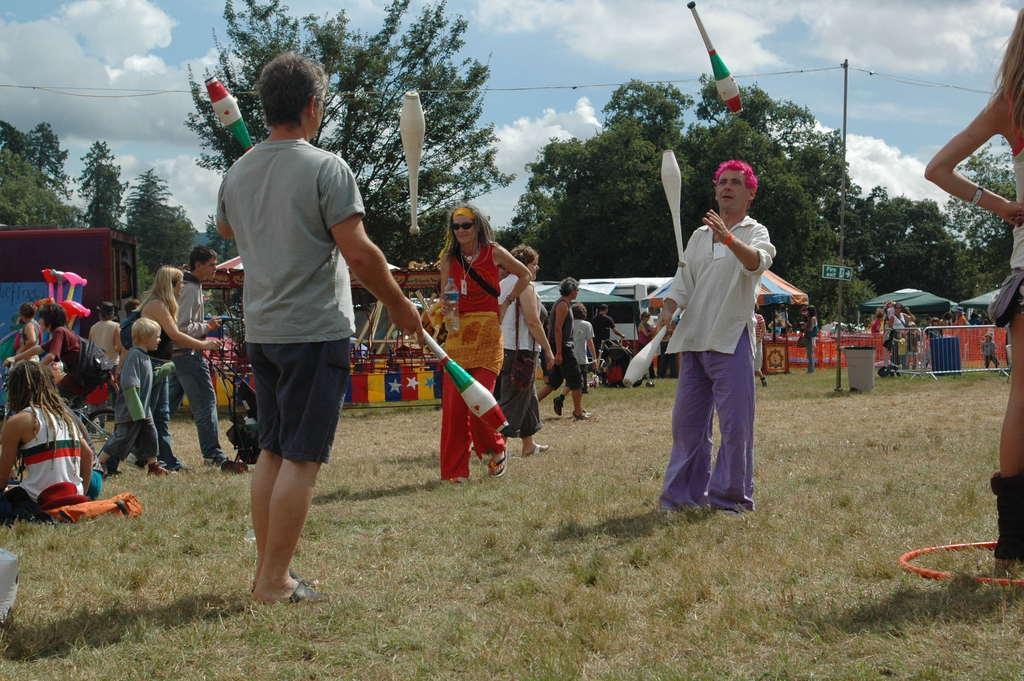In one or two sentences, can you explain what this image depicts? In the image we can see there are people standing and they are playing with objects. There are other people sitting on the ground and the ground is covered with grass. Behind there are stalls and there are trees. There is a cloudy sky. 